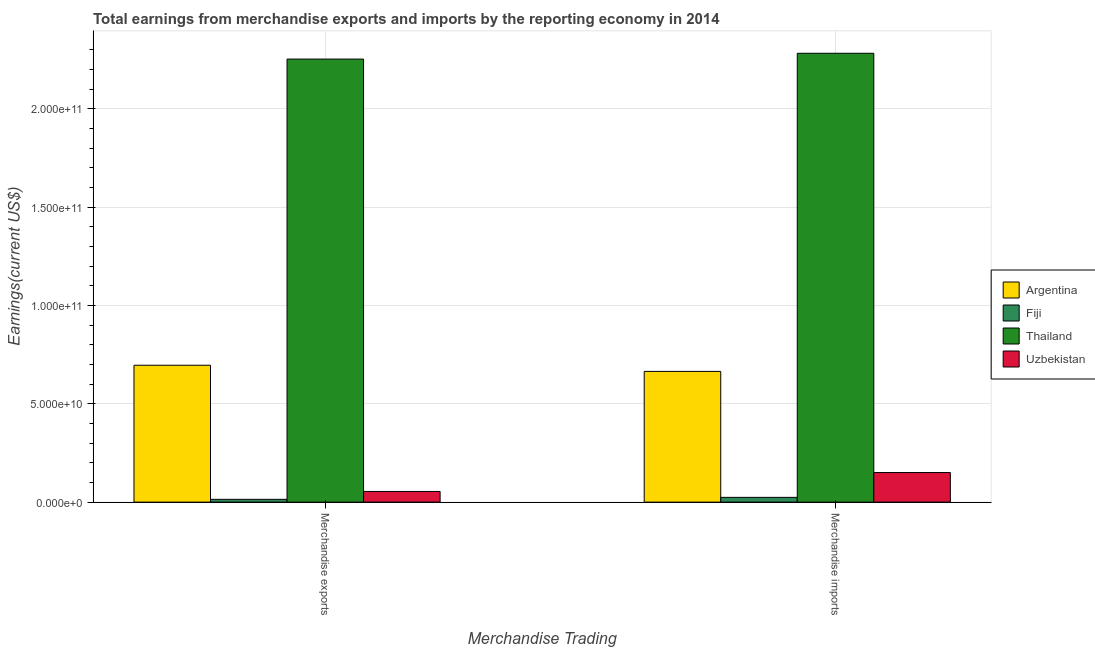How many different coloured bars are there?
Provide a short and direct response. 4. How many bars are there on the 1st tick from the left?
Make the answer very short. 4. What is the earnings from merchandise exports in Argentina?
Provide a short and direct response. 6.96e+1. Across all countries, what is the maximum earnings from merchandise exports?
Your answer should be compact. 2.25e+11. Across all countries, what is the minimum earnings from merchandise exports?
Provide a succinct answer. 1.42e+09. In which country was the earnings from merchandise exports maximum?
Offer a terse response. Thailand. In which country was the earnings from merchandise imports minimum?
Offer a terse response. Fiji. What is the total earnings from merchandise imports in the graph?
Your answer should be compact. 3.12e+11. What is the difference between the earnings from merchandise exports in Thailand and that in Argentina?
Your answer should be very brief. 1.56e+11. What is the difference between the earnings from merchandise imports in Uzbekistan and the earnings from merchandise exports in Argentina?
Give a very brief answer. -5.45e+1. What is the average earnings from merchandise exports per country?
Give a very brief answer. 7.54e+1. What is the difference between the earnings from merchandise exports and earnings from merchandise imports in Uzbekistan?
Ensure brevity in your answer.  -9.62e+09. What is the ratio of the earnings from merchandise exports in Thailand to that in Fiji?
Your response must be concise. 159.12. Is the earnings from merchandise imports in Uzbekistan less than that in Fiji?
Your response must be concise. No. In how many countries, is the earnings from merchandise imports greater than the average earnings from merchandise imports taken over all countries?
Make the answer very short. 1. What does the 2nd bar from the left in Merchandise imports represents?
Your answer should be compact. Fiji. What does the 4th bar from the right in Merchandise exports represents?
Ensure brevity in your answer.  Argentina. How many bars are there?
Your response must be concise. 8. How many countries are there in the graph?
Provide a succinct answer. 4. What is the difference between two consecutive major ticks on the Y-axis?
Your answer should be very brief. 5.00e+1. Are the values on the major ticks of Y-axis written in scientific E-notation?
Offer a very short reply. Yes. Does the graph contain any zero values?
Provide a succinct answer. No. Where does the legend appear in the graph?
Give a very brief answer. Center right. How many legend labels are there?
Offer a very short reply. 4. What is the title of the graph?
Make the answer very short. Total earnings from merchandise exports and imports by the reporting economy in 2014. What is the label or title of the X-axis?
Keep it short and to the point. Merchandise Trading. What is the label or title of the Y-axis?
Offer a terse response. Earnings(current US$). What is the Earnings(current US$) in Argentina in Merchandise exports?
Give a very brief answer. 6.96e+1. What is the Earnings(current US$) of Fiji in Merchandise exports?
Keep it short and to the point. 1.42e+09. What is the Earnings(current US$) of Thailand in Merchandise exports?
Make the answer very short. 2.25e+11. What is the Earnings(current US$) of Uzbekistan in Merchandise exports?
Make the answer very short. 5.43e+09. What is the Earnings(current US$) of Argentina in Merchandise imports?
Give a very brief answer. 6.65e+1. What is the Earnings(current US$) in Fiji in Merchandise imports?
Keep it short and to the point. 2.42e+09. What is the Earnings(current US$) in Thailand in Merchandise imports?
Offer a very short reply. 2.28e+11. What is the Earnings(current US$) in Uzbekistan in Merchandise imports?
Your response must be concise. 1.50e+1. Across all Merchandise Trading, what is the maximum Earnings(current US$) of Argentina?
Ensure brevity in your answer.  6.96e+1. Across all Merchandise Trading, what is the maximum Earnings(current US$) in Fiji?
Your answer should be very brief. 2.42e+09. Across all Merchandise Trading, what is the maximum Earnings(current US$) in Thailand?
Your answer should be very brief. 2.28e+11. Across all Merchandise Trading, what is the maximum Earnings(current US$) of Uzbekistan?
Your response must be concise. 1.50e+1. Across all Merchandise Trading, what is the minimum Earnings(current US$) in Argentina?
Offer a terse response. 6.65e+1. Across all Merchandise Trading, what is the minimum Earnings(current US$) of Fiji?
Ensure brevity in your answer.  1.42e+09. Across all Merchandise Trading, what is the minimum Earnings(current US$) in Thailand?
Ensure brevity in your answer.  2.25e+11. Across all Merchandise Trading, what is the minimum Earnings(current US$) in Uzbekistan?
Offer a very short reply. 5.43e+09. What is the total Earnings(current US$) of Argentina in the graph?
Your answer should be compact. 1.36e+11. What is the total Earnings(current US$) of Fiji in the graph?
Keep it short and to the point. 3.84e+09. What is the total Earnings(current US$) in Thailand in the graph?
Your answer should be very brief. 4.53e+11. What is the total Earnings(current US$) of Uzbekistan in the graph?
Offer a very short reply. 2.05e+1. What is the difference between the Earnings(current US$) in Argentina in Merchandise exports and that in Merchandise imports?
Keep it short and to the point. 3.12e+09. What is the difference between the Earnings(current US$) in Fiji in Merchandise exports and that in Merchandise imports?
Provide a succinct answer. -1.00e+09. What is the difference between the Earnings(current US$) of Thailand in Merchandise exports and that in Merchandise imports?
Provide a short and direct response. -2.96e+09. What is the difference between the Earnings(current US$) of Uzbekistan in Merchandise exports and that in Merchandise imports?
Give a very brief answer. -9.62e+09. What is the difference between the Earnings(current US$) of Argentina in Merchandise exports and the Earnings(current US$) of Fiji in Merchandise imports?
Your answer should be compact. 6.72e+1. What is the difference between the Earnings(current US$) of Argentina in Merchandise exports and the Earnings(current US$) of Thailand in Merchandise imports?
Make the answer very short. -1.59e+11. What is the difference between the Earnings(current US$) of Argentina in Merchandise exports and the Earnings(current US$) of Uzbekistan in Merchandise imports?
Your answer should be compact. 5.45e+1. What is the difference between the Earnings(current US$) in Fiji in Merchandise exports and the Earnings(current US$) in Thailand in Merchandise imports?
Ensure brevity in your answer.  -2.27e+11. What is the difference between the Earnings(current US$) of Fiji in Merchandise exports and the Earnings(current US$) of Uzbekistan in Merchandise imports?
Your answer should be compact. -1.36e+1. What is the difference between the Earnings(current US$) of Thailand in Merchandise exports and the Earnings(current US$) of Uzbekistan in Merchandise imports?
Make the answer very short. 2.10e+11. What is the average Earnings(current US$) of Argentina per Merchandise Trading?
Provide a succinct answer. 6.80e+1. What is the average Earnings(current US$) of Fiji per Merchandise Trading?
Make the answer very short. 1.92e+09. What is the average Earnings(current US$) in Thailand per Merchandise Trading?
Offer a terse response. 2.27e+11. What is the average Earnings(current US$) of Uzbekistan per Merchandise Trading?
Keep it short and to the point. 1.02e+1. What is the difference between the Earnings(current US$) of Argentina and Earnings(current US$) of Fiji in Merchandise exports?
Make the answer very short. 6.82e+1. What is the difference between the Earnings(current US$) in Argentina and Earnings(current US$) in Thailand in Merchandise exports?
Keep it short and to the point. -1.56e+11. What is the difference between the Earnings(current US$) of Argentina and Earnings(current US$) of Uzbekistan in Merchandise exports?
Ensure brevity in your answer.  6.42e+1. What is the difference between the Earnings(current US$) in Fiji and Earnings(current US$) in Thailand in Merchandise exports?
Ensure brevity in your answer.  -2.24e+11. What is the difference between the Earnings(current US$) of Fiji and Earnings(current US$) of Uzbekistan in Merchandise exports?
Your response must be concise. -4.01e+09. What is the difference between the Earnings(current US$) of Thailand and Earnings(current US$) of Uzbekistan in Merchandise exports?
Keep it short and to the point. 2.20e+11. What is the difference between the Earnings(current US$) in Argentina and Earnings(current US$) in Fiji in Merchandise imports?
Your answer should be compact. 6.40e+1. What is the difference between the Earnings(current US$) in Argentina and Earnings(current US$) in Thailand in Merchandise imports?
Give a very brief answer. -1.62e+11. What is the difference between the Earnings(current US$) in Argentina and Earnings(current US$) in Uzbekistan in Merchandise imports?
Give a very brief answer. 5.14e+1. What is the difference between the Earnings(current US$) in Fiji and Earnings(current US$) in Thailand in Merchandise imports?
Provide a succinct answer. -2.26e+11. What is the difference between the Earnings(current US$) of Fiji and Earnings(current US$) of Uzbekistan in Merchandise imports?
Your answer should be very brief. -1.26e+1. What is the difference between the Earnings(current US$) of Thailand and Earnings(current US$) of Uzbekistan in Merchandise imports?
Make the answer very short. 2.13e+11. What is the ratio of the Earnings(current US$) of Argentina in Merchandise exports to that in Merchandise imports?
Your answer should be very brief. 1.05. What is the ratio of the Earnings(current US$) of Fiji in Merchandise exports to that in Merchandise imports?
Give a very brief answer. 0.58. What is the ratio of the Earnings(current US$) in Thailand in Merchandise exports to that in Merchandise imports?
Provide a succinct answer. 0.99. What is the ratio of the Earnings(current US$) in Uzbekistan in Merchandise exports to that in Merchandise imports?
Give a very brief answer. 0.36. What is the difference between the highest and the second highest Earnings(current US$) in Argentina?
Provide a succinct answer. 3.12e+09. What is the difference between the highest and the second highest Earnings(current US$) in Fiji?
Your response must be concise. 1.00e+09. What is the difference between the highest and the second highest Earnings(current US$) of Thailand?
Your answer should be very brief. 2.96e+09. What is the difference between the highest and the second highest Earnings(current US$) of Uzbekistan?
Make the answer very short. 9.62e+09. What is the difference between the highest and the lowest Earnings(current US$) of Argentina?
Provide a short and direct response. 3.12e+09. What is the difference between the highest and the lowest Earnings(current US$) of Fiji?
Make the answer very short. 1.00e+09. What is the difference between the highest and the lowest Earnings(current US$) in Thailand?
Offer a very short reply. 2.96e+09. What is the difference between the highest and the lowest Earnings(current US$) of Uzbekistan?
Provide a succinct answer. 9.62e+09. 